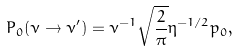<formula> <loc_0><loc_0><loc_500><loc_500>P _ { 0 } ( \nu \rightarrow \nu ^ { \prime } ) = \nu ^ { - 1 } \sqrt { \frac { 2 } { \pi } } \eta ^ { - 1 / 2 } p _ { 0 } ,</formula> 